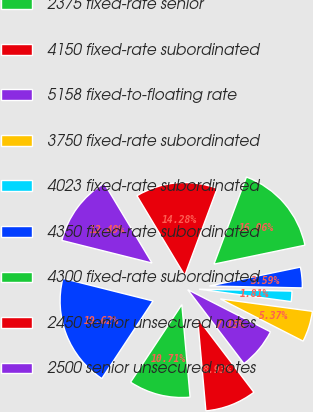Convert chart. <chart><loc_0><loc_0><loc_500><loc_500><pie_chart><fcel>(in millions)<fcel>2375 fixed-rate senior<fcel>4150 fixed-rate subordinated<fcel>5158 fixed-to-floating rate<fcel>3750 fixed-rate subordinated<fcel>4023 fixed-rate subordinated<fcel>4350 fixed-rate subordinated<fcel>4300 fixed-rate subordinated<fcel>2450 senior unsecured notes<fcel>2500 senior unsecured notes<nl><fcel>19.62%<fcel>10.71%<fcel>8.93%<fcel>7.15%<fcel>5.37%<fcel>1.81%<fcel>3.59%<fcel>16.06%<fcel>14.28%<fcel>12.49%<nl></chart> 